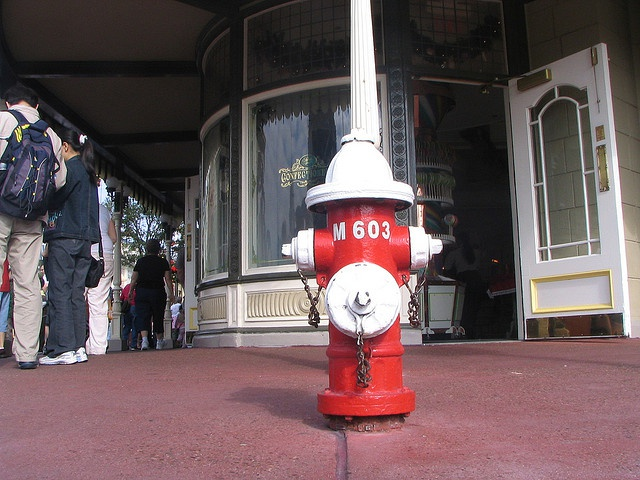Describe the objects in this image and their specific colors. I can see fire hydrant in black, white, red, salmon, and brown tones, people in black, lightgray, gray, and darkgray tones, people in black, gray, and darkblue tones, backpack in black, gray, and darkblue tones, and people in black, gray, and darkgray tones in this image. 